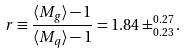Convert formula to latex. <formula><loc_0><loc_0><loc_500><loc_500>r \equiv \frac { \langle M _ { g } \rangle - 1 } { \langle M _ { q } \rangle - 1 } = 1 . 8 4 \pm ^ { 0 . 2 7 } _ { 0 . 2 3 } .</formula> 